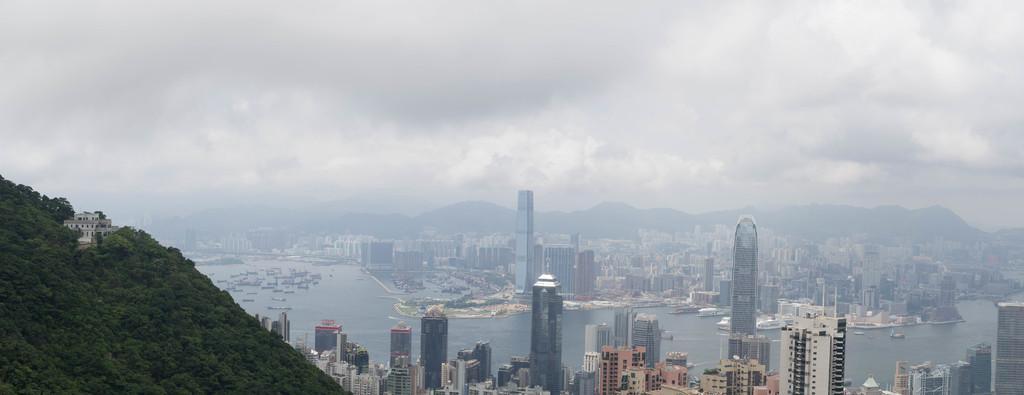Please provide a concise description of this image. In the picture I can see buildings, trees, boats on the water and some other objects. In the background I can see mountains and the sky. 